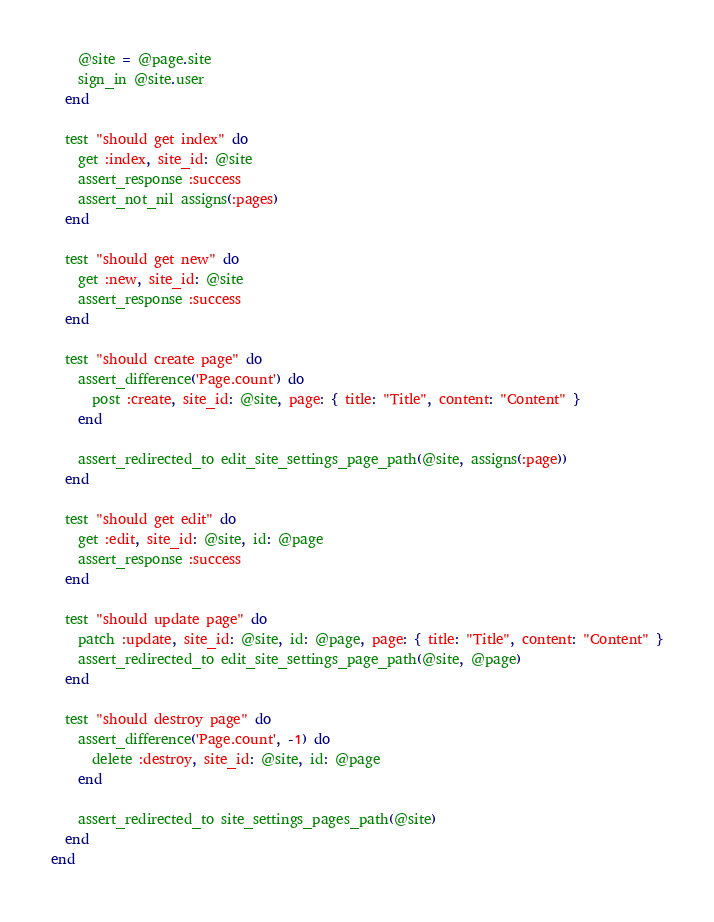<code> <loc_0><loc_0><loc_500><loc_500><_Ruby_>    @site = @page.site
    sign_in @site.user
  end

  test "should get index" do
    get :index, site_id: @site
    assert_response :success
    assert_not_nil assigns(:pages)
  end

  test "should get new" do
    get :new, site_id: @site
    assert_response :success
  end

  test "should create page" do
    assert_difference('Page.count') do
      post :create, site_id: @site, page: { title: "Title", content: "Content" }
    end

    assert_redirected_to edit_site_settings_page_path(@site, assigns(:page))
  end

  test "should get edit" do
    get :edit, site_id: @site, id: @page
    assert_response :success
  end

  test "should update page" do
    patch :update, site_id: @site, id: @page, page: { title: "Title", content: "Content" }
    assert_redirected_to edit_site_settings_page_path(@site, @page)
  end

  test "should destroy page" do
    assert_difference('Page.count', -1) do
      delete :destroy, site_id: @site, id: @page
    end

    assert_redirected_to site_settings_pages_path(@site)
  end
end
</code> 